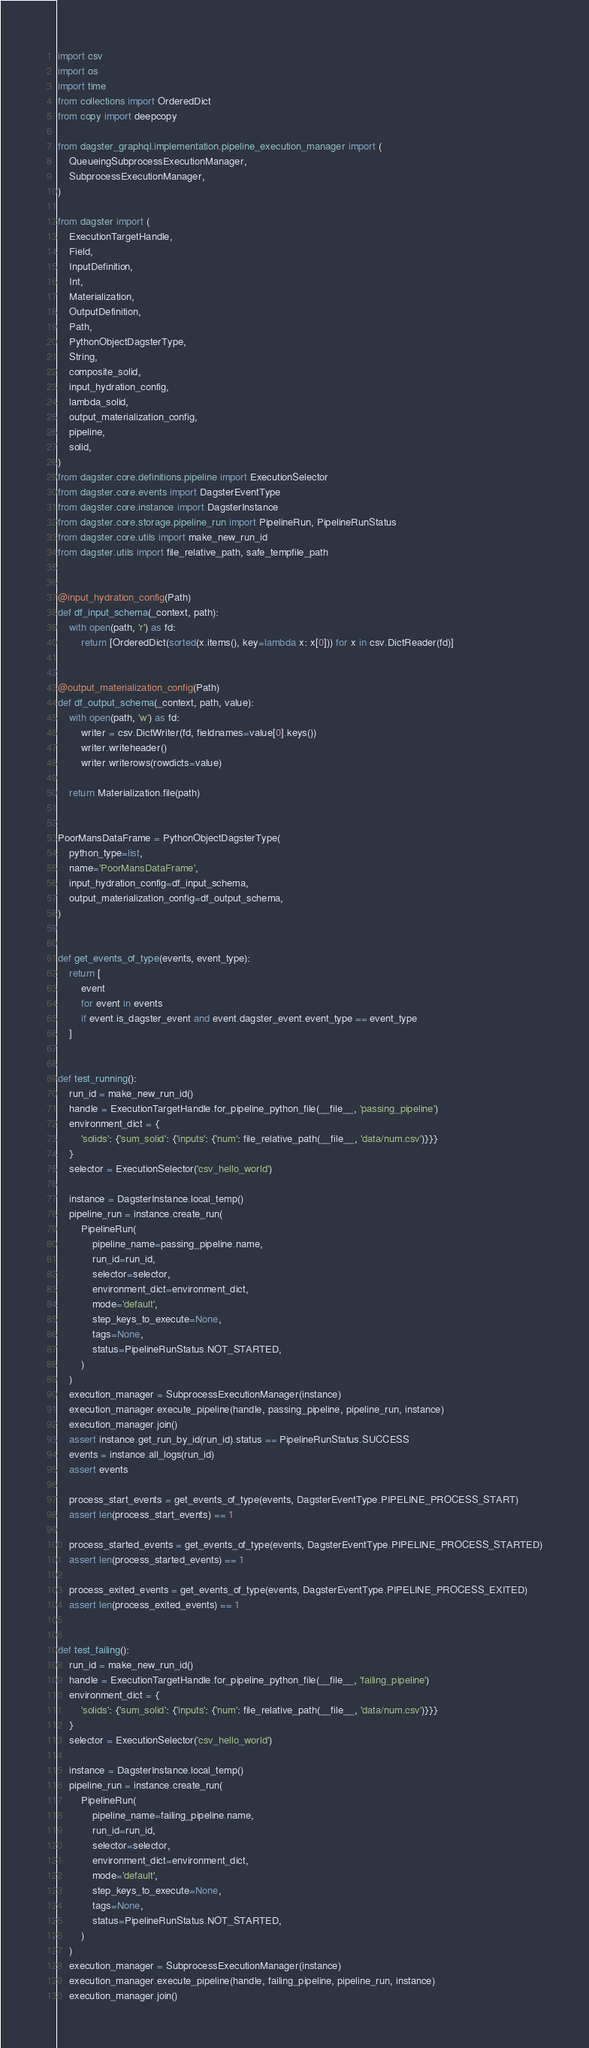Convert code to text. <code><loc_0><loc_0><loc_500><loc_500><_Python_>import csv
import os
import time
from collections import OrderedDict
from copy import deepcopy

from dagster_graphql.implementation.pipeline_execution_manager import (
    QueueingSubprocessExecutionManager,
    SubprocessExecutionManager,
)

from dagster import (
    ExecutionTargetHandle,
    Field,
    InputDefinition,
    Int,
    Materialization,
    OutputDefinition,
    Path,
    PythonObjectDagsterType,
    String,
    composite_solid,
    input_hydration_config,
    lambda_solid,
    output_materialization_config,
    pipeline,
    solid,
)
from dagster.core.definitions.pipeline import ExecutionSelector
from dagster.core.events import DagsterEventType
from dagster.core.instance import DagsterInstance
from dagster.core.storage.pipeline_run import PipelineRun, PipelineRunStatus
from dagster.core.utils import make_new_run_id
from dagster.utils import file_relative_path, safe_tempfile_path


@input_hydration_config(Path)
def df_input_schema(_context, path):
    with open(path, 'r') as fd:
        return [OrderedDict(sorted(x.items(), key=lambda x: x[0])) for x in csv.DictReader(fd)]


@output_materialization_config(Path)
def df_output_schema(_context, path, value):
    with open(path, 'w') as fd:
        writer = csv.DictWriter(fd, fieldnames=value[0].keys())
        writer.writeheader()
        writer.writerows(rowdicts=value)

    return Materialization.file(path)


PoorMansDataFrame = PythonObjectDagsterType(
    python_type=list,
    name='PoorMansDataFrame',
    input_hydration_config=df_input_schema,
    output_materialization_config=df_output_schema,
)


def get_events_of_type(events, event_type):
    return [
        event
        for event in events
        if event.is_dagster_event and event.dagster_event.event_type == event_type
    ]


def test_running():
    run_id = make_new_run_id()
    handle = ExecutionTargetHandle.for_pipeline_python_file(__file__, 'passing_pipeline')
    environment_dict = {
        'solids': {'sum_solid': {'inputs': {'num': file_relative_path(__file__, 'data/num.csv')}}}
    }
    selector = ExecutionSelector('csv_hello_world')

    instance = DagsterInstance.local_temp()
    pipeline_run = instance.create_run(
        PipelineRun(
            pipeline_name=passing_pipeline.name,
            run_id=run_id,
            selector=selector,
            environment_dict=environment_dict,
            mode='default',
            step_keys_to_execute=None,
            tags=None,
            status=PipelineRunStatus.NOT_STARTED,
        )
    )
    execution_manager = SubprocessExecutionManager(instance)
    execution_manager.execute_pipeline(handle, passing_pipeline, pipeline_run, instance)
    execution_manager.join()
    assert instance.get_run_by_id(run_id).status == PipelineRunStatus.SUCCESS
    events = instance.all_logs(run_id)
    assert events

    process_start_events = get_events_of_type(events, DagsterEventType.PIPELINE_PROCESS_START)
    assert len(process_start_events) == 1

    process_started_events = get_events_of_type(events, DagsterEventType.PIPELINE_PROCESS_STARTED)
    assert len(process_started_events) == 1

    process_exited_events = get_events_of_type(events, DagsterEventType.PIPELINE_PROCESS_EXITED)
    assert len(process_exited_events) == 1


def test_failing():
    run_id = make_new_run_id()
    handle = ExecutionTargetHandle.for_pipeline_python_file(__file__, 'failing_pipeline')
    environment_dict = {
        'solids': {'sum_solid': {'inputs': {'num': file_relative_path(__file__, 'data/num.csv')}}}
    }
    selector = ExecutionSelector('csv_hello_world')

    instance = DagsterInstance.local_temp()
    pipeline_run = instance.create_run(
        PipelineRun(
            pipeline_name=failing_pipeline.name,
            run_id=run_id,
            selector=selector,
            environment_dict=environment_dict,
            mode='default',
            step_keys_to_execute=None,
            tags=None,
            status=PipelineRunStatus.NOT_STARTED,
        )
    )
    execution_manager = SubprocessExecutionManager(instance)
    execution_manager.execute_pipeline(handle, failing_pipeline, pipeline_run, instance)
    execution_manager.join()</code> 